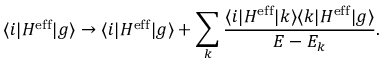<formula> <loc_0><loc_0><loc_500><loc_500>\langle i | H ^ { e f f } | g \rangle \rightarrow \langle i | H ^ { e f f } | g \rangle + \sum _ { k } \frac { \langle i | H ^ { e f f } | k \rangle \langle k | H ^ { e f f } | g \rangle } { E - E _ { k } } .</formula> 